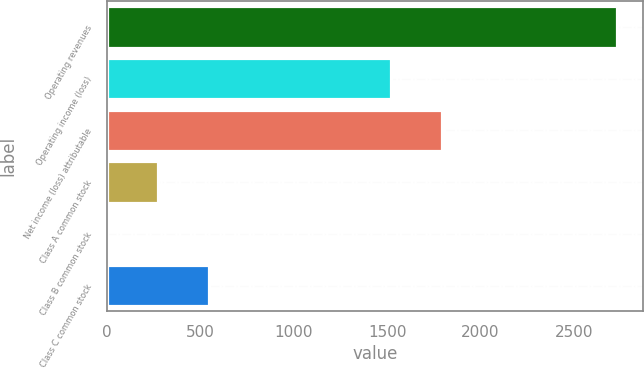<chart> <loc_0><loc_0><loc_500><loc_500><bar_chart><fcel>Operating revenues<fcel>Operating income (loss)<fcel>Net income (loss) attributable<fcel>Class A common stock<fcel>Class B common stock<fcel>Class C common stock<nl><fcel>2731<fcel>1522<fcel>1794.99<fcel>274.05<fcel>1.05<fcel>547.05<nl></chart> 